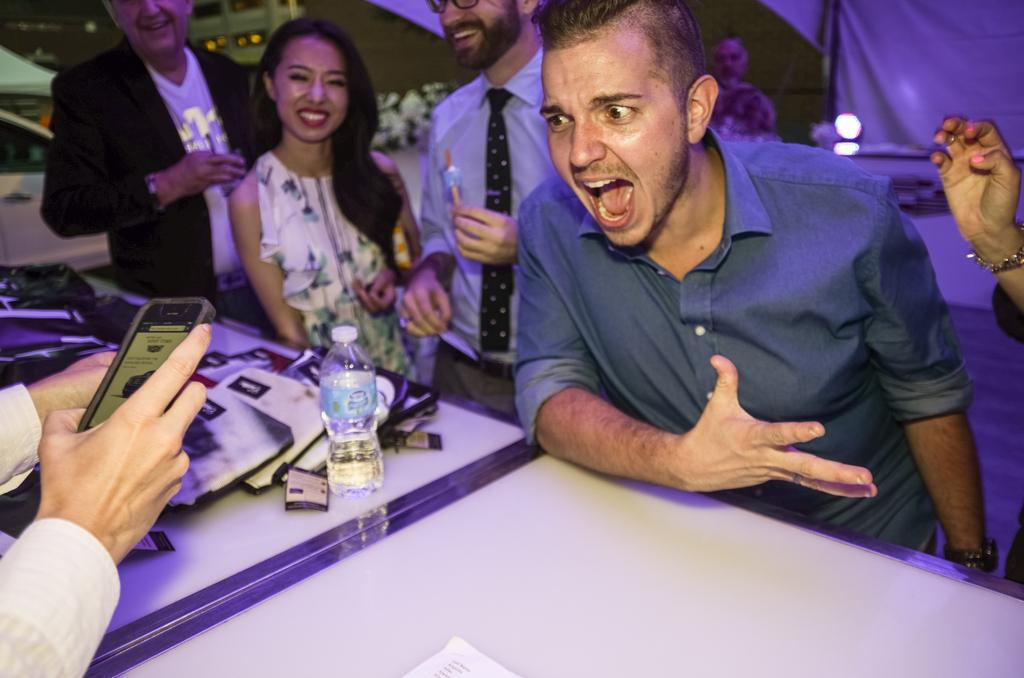What is happening in the image involving a group of people? There is a group of people in the image, but their specific activity is not mentioned in the facts. Can you describe the person sitting in front of the table? The person sitting in front of the table is wearing a blue shirt. What is on the table in the image? There is a bottle on the table. What is the color of the person's shirt? The person is wearing a blue shirt. What type of hook is the person using to adjust the design of their trousers in the image? There is no hook or trousers present in the image, and therefore no such activity can be observed. 